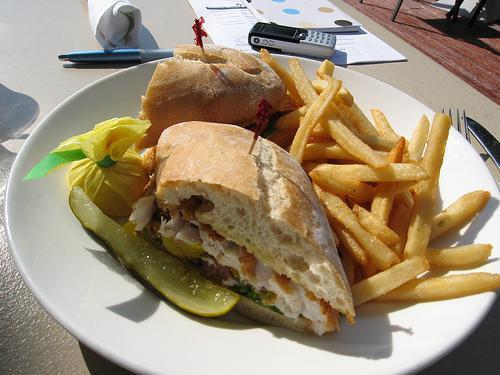How many plates are there?
Give a very brief answer. 1. 